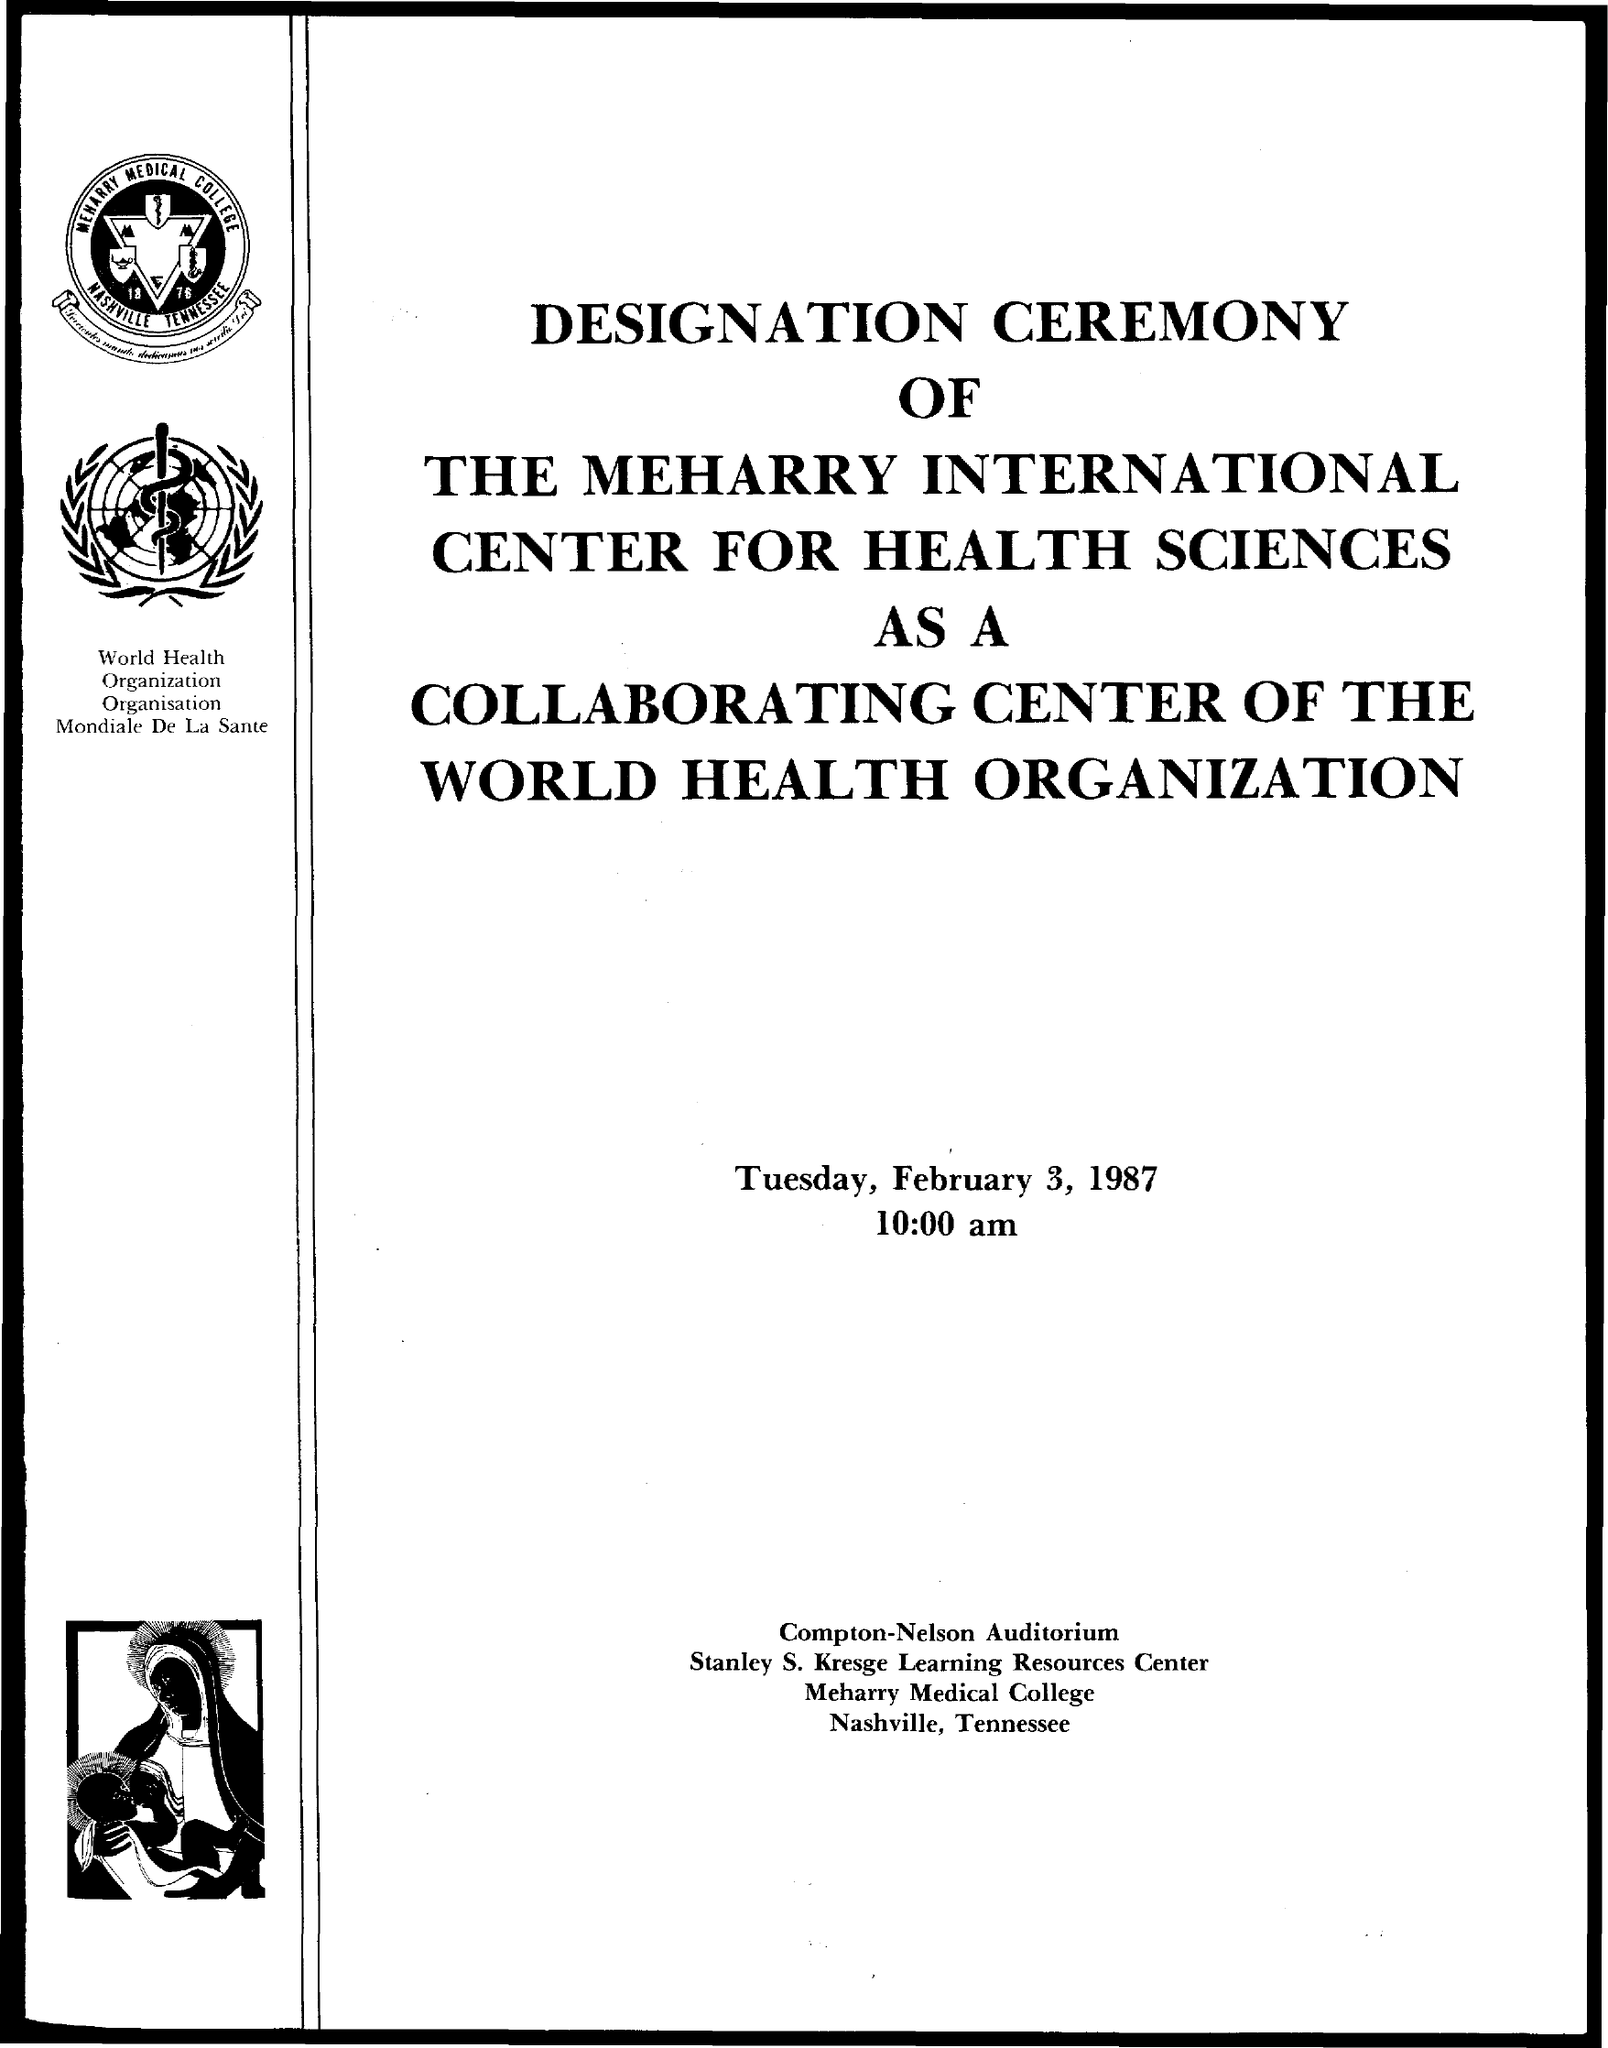Highlight a few significant elements in this photo. The date mentioned in the given page is Tuesday, February 3, 1987. The time mentioned is 10:00 am. The college named Meharry Medical College was mentioned. 